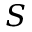Convert formula to latex. <formula><loc_0><loc_0><loc_500><loc_500>S</formula> 